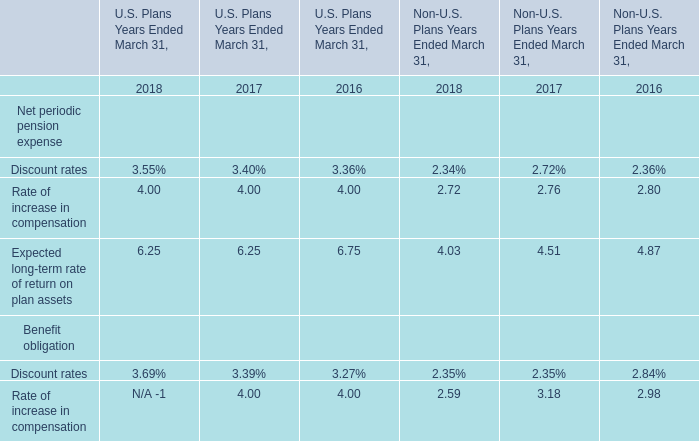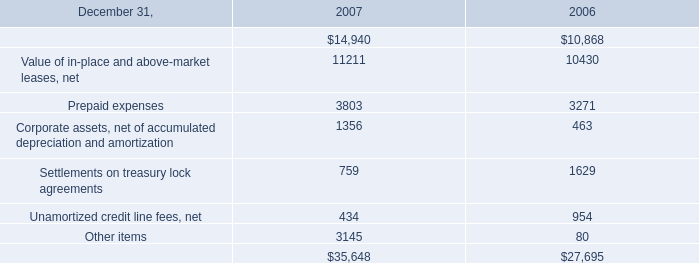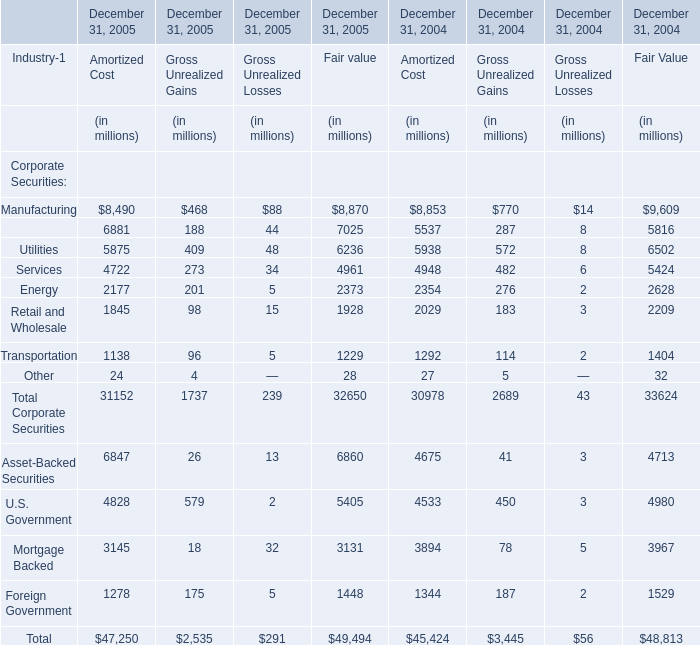What is the ratio of all elements for Amortized Cost that are smaller than 2000 to the sum of elements in 2005? 
Computations: ((((1845 + 1138) + 24) + 1278) / 47250)
Answer: 0.09069. 